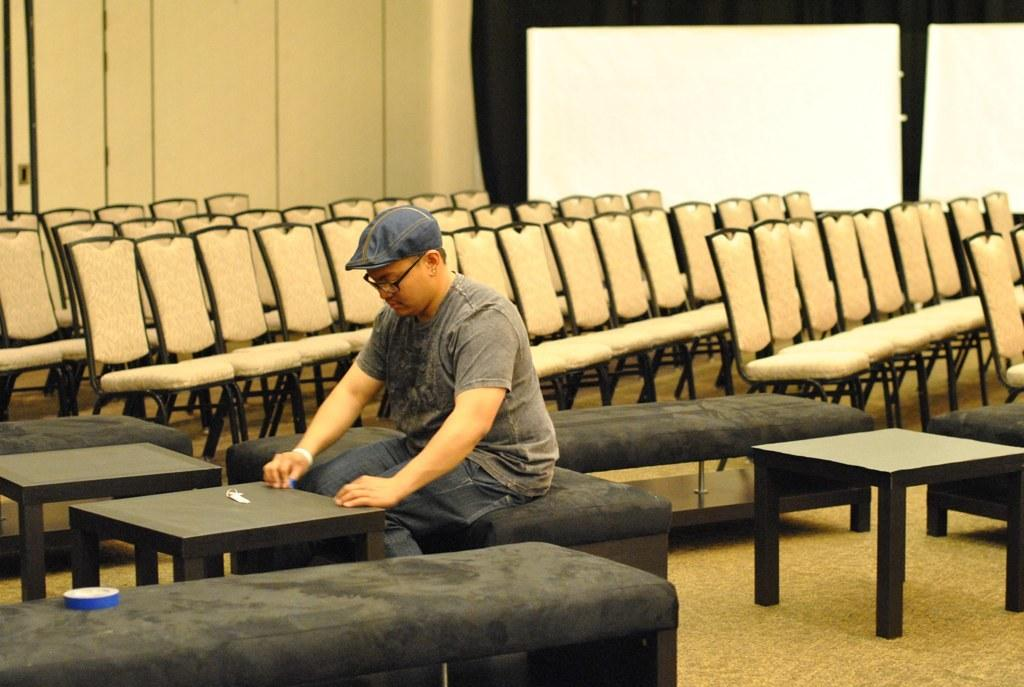What is the person in the room doing? The person is sitting in the room. Where is the person sitting? The person is sitting on a bench. What other seating options are available in the room? There are chairs in the room. What is the person pointing at in the room? There is no indication in the image that the person is pointing at anything. 